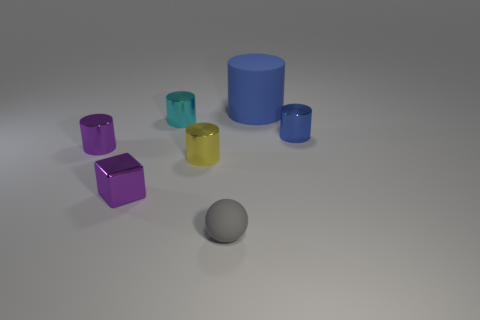Subtract all purple cylinders. How many cylinders are left? 4 Subtract all small purple cylinders. How many cylinders are left? 4 Subtract all cyan cylinders. Subtract all cyan blocks. How many cylinders are left? 4 Add 2 tiny cylinders. How many objects exist? 9 Subtract all balls. How many objects are left? 6 Subtract all small red matte spheres. Subtract all blocks. How many objects are left? 6 Add 2 rubber things. How many rubber things are left? 4 Add 7 gray rubber objects. How many gray rubber objects exist? 8 Subtract 0 brown cylinders. How many objects are left? 7 